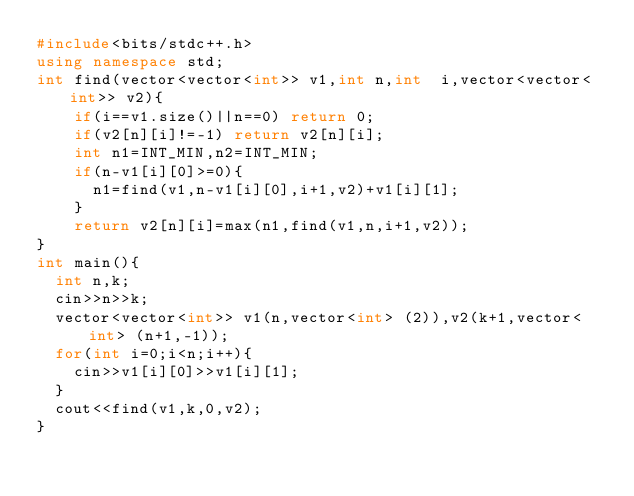<code> <loc_0><loc_0><loc_500><loc_500><_C++_>#include<bits/stdc++.h>
using namespace std;
int find(vector<vector<int>> v1,int n,int  i,vector<vector<int>> v2){
	if(i==v1.size()||n==0) return 0;
  	if(v2[n][i]!=-1) return v2[n][i];
  	int n1=INT_MIN,n2=INT_MIN;
    if(n-v1[i][0]>=0){
      n1=find(v1,n-v1[i][0],i+1,v2)+v1[i][1];
    }
  	return v2[n][i]=max(n1,find(v1,n,i+1,v2));
}
int main(){
  int n,k;
  cin>>n>>k;
  vector<vector<int>> v1(n,vector<int> (2)),v2(k+1,vector<int> (n+1,-1));
  for(int i=0;i<n;i++){
    cin>>v1[i][0]>>v1[i][1];
  }
  cout<<find(v1,k,0,v2);
}</code> 